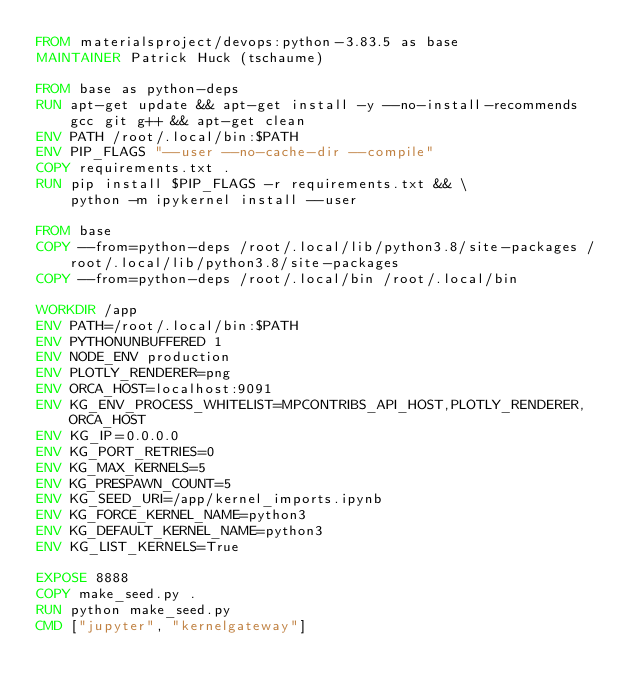Convert code to text. <code><loc_0><loc_0><loc_500><loc_500><_Dockerfile_>FROM materialsproject/devops:python-3.83.5 as base
MAINTAINER Patrick Huck (tschaume)

FROM base as python-deps
RUN apt-get update && apt-get install -y --no-install-recommends gcc git g++ && apt-get clean
ENV PATH /root/.local/bin:$PATH
ENV PIP_FLAGS "--user --no-cache-dir --compile"
COPY requirements.txt .
RUN pip install $PIP_FLAGS -r requirements.txt && \
    python -m ipykernel install --user

FROM base
COPY --from=python-deps /root/.local/lib/python3.8/site-packages /root/.local/lib/python3.8/site-packages
COPY --from=python-deps /root/.local/bin /root/.local/bin

WORKDIR /app
ENV PATH=/root/.local/bin:$PATH
ENV PYTHONUNBUFFERED 1
ENV NODE_ENV production
ENV PLOTLY_RENDERER=png
ENV ORCA_HOST=localhost:9091
ENV KG_ENV_PROCESS_WHITELIST=MPCONTRIBS_API_HOST,PLOTLY_RENDERER,ORCA_HOST
ENV KG_IP=0.0.0.0
ENV KG_PORT_RETRIES=0
ENV KG_MAX_KERNELS=5
ENV KG_PRESPAWN_COUNT=5
ENV KG_SEED_URI=/app/kernel_imports.ipynb
ENV KG_FORCE_KERNEL_NAME=python3
ENV KG_DEFAULT_KERNEL_NAME=python3
ENV KG_LIST_KERNELS=True

EXPOSE 8888
COPY make_seed.py .
RUN python make_seed.py
CMD ["jupyter", "kernelgateway"]
</code> 